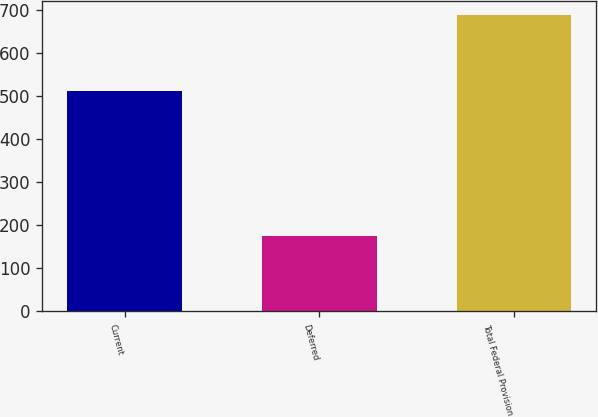Convert chart. <chart><loc_0><loc_0><loc_500><loc_500><bar_chart><fcel>Current<fcel>Deferred<fcel>Total Federal Provision<nl><fcel>512<fcel>175<fcel>687<nl></chart> 